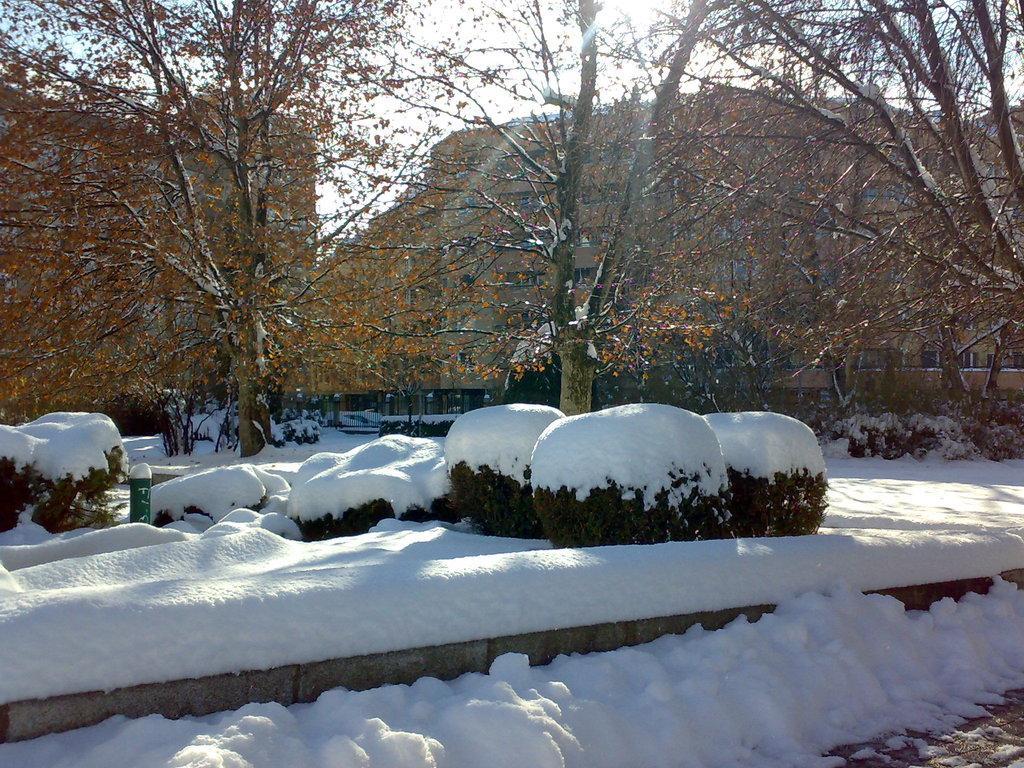Can you describe this image briefly? In this image I can see some plants covered with the snow. In the background I can see many trees, houses and the sky. 